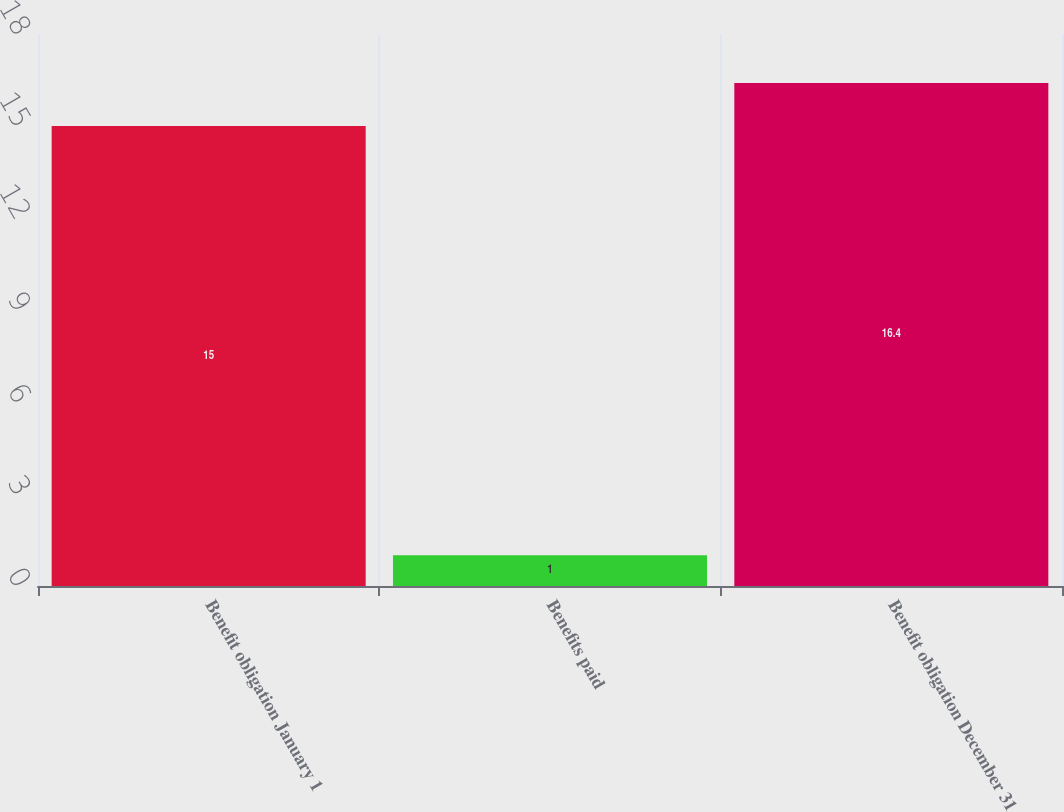Convert chart to OTSL. <chart><loc_0><loc_0><loc_500><loc_500><bar_chart><fcel>Benefit obligation January 1<fcel>Benefits paid<fcel>Benefit obligation December 31<nl><fcel>15<fcel>1<fcel>16.4<nl></chart> 